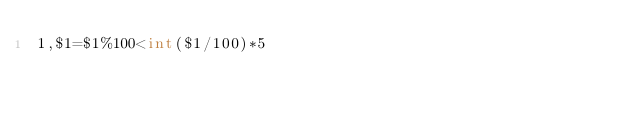Convert code to text. <code><loc_0><loc_0><loc_500><loc_500><_Awk_>1,$1=$1%100<int($1/100)*5</code> 